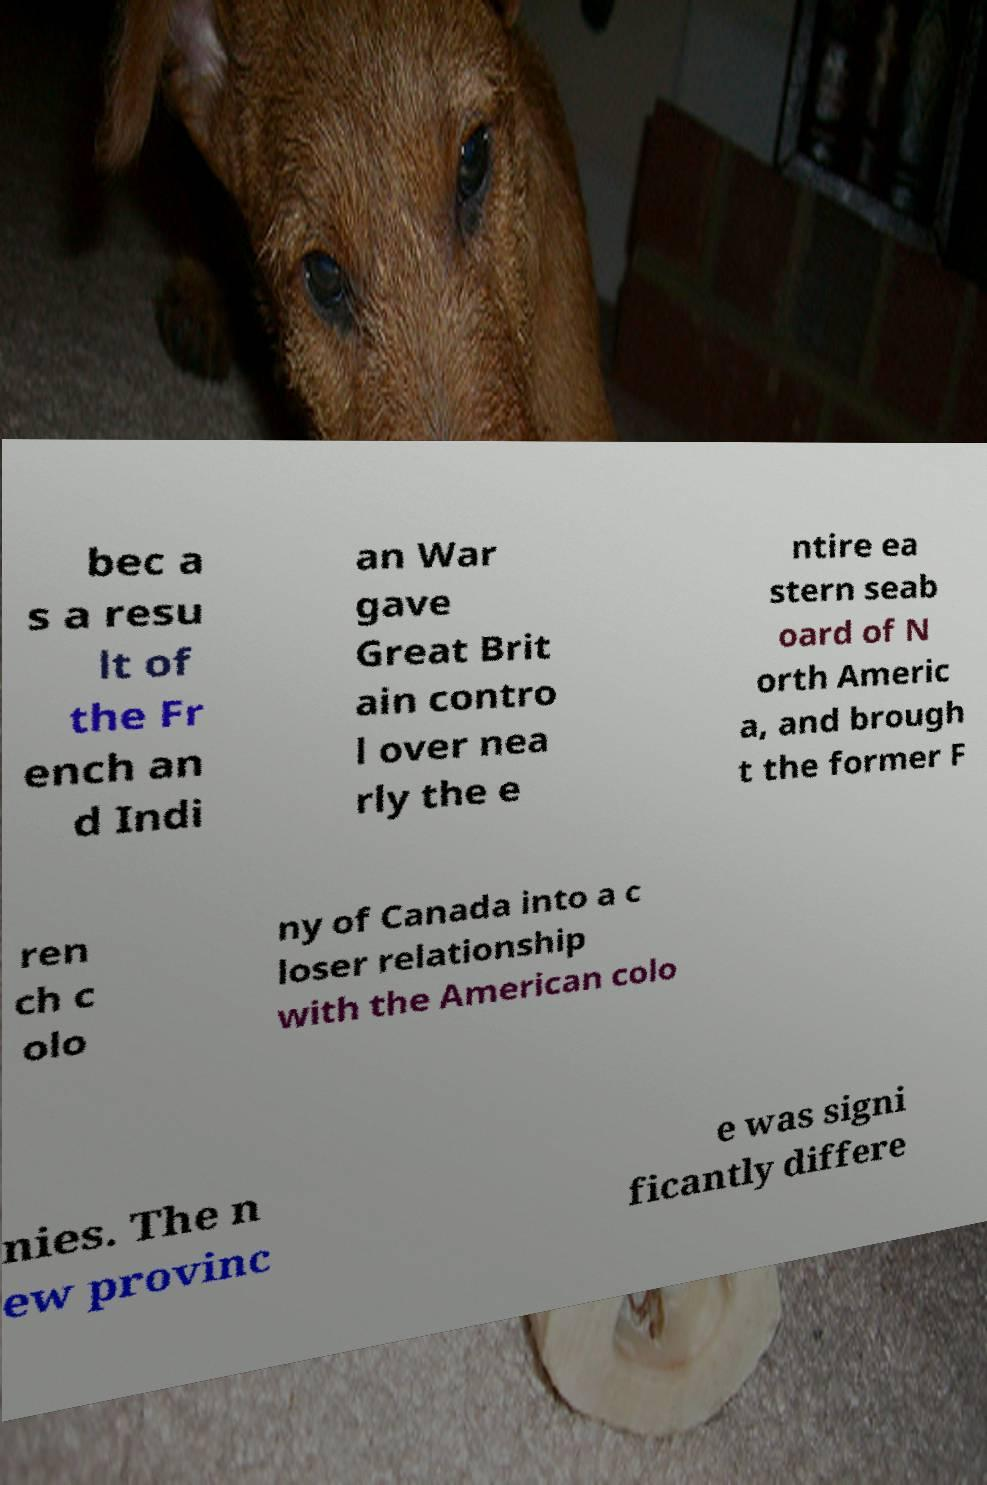Please read and relay the text visible in this image. What does it say? bec a s a resu lt of the Fr ench an d Indi an War gave Great Brit ain contro l over nea rly the e ntire ea stern seab oard of N orth Americ a, and brough t the former F ren ch c olo ny of Canada into a c loser relationship with the American colo nies. The n ew provinc e was signi ficantly differe 